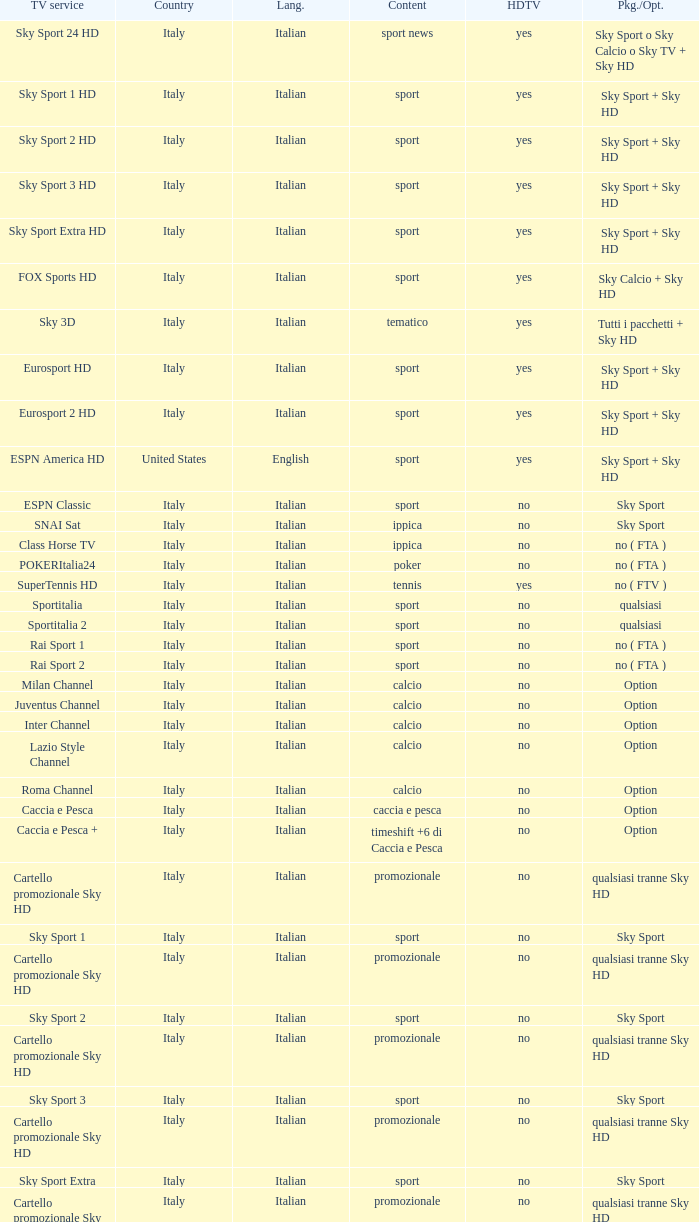What is Package/Option, when Content is Poker? No ( fta ). 